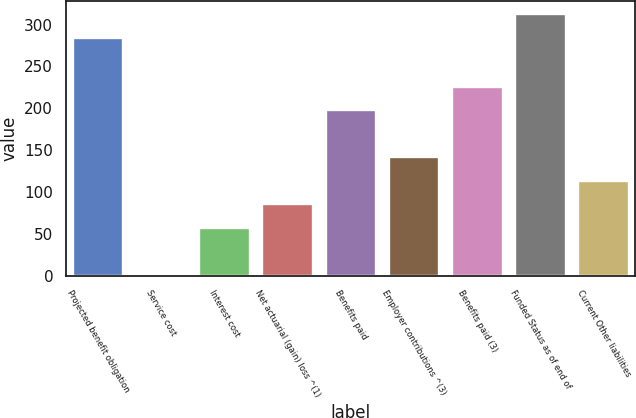Convert chart. <chart><loc_0><loc_0><loc_500><loc_500><bar_chart><fcel>Projected benefit obligation<fcel>Service cost<fcel>Interest cost<fcel>Net actuarial (gain) loss ^(1)<fcel>Benefits paid<fcel>Employer contributions ^(3)<fcel>Benefits paid (3)<fcel>Funded Status as of end of<fcel>Current Other liabilities<nl><fcel>284.1<fcel>1<fcel>57.2<fcel>85.3<fcel>197.7<fcel>141.5<fcel>225.8<fcel>312.2<fcel>113.4<nl></chart> 